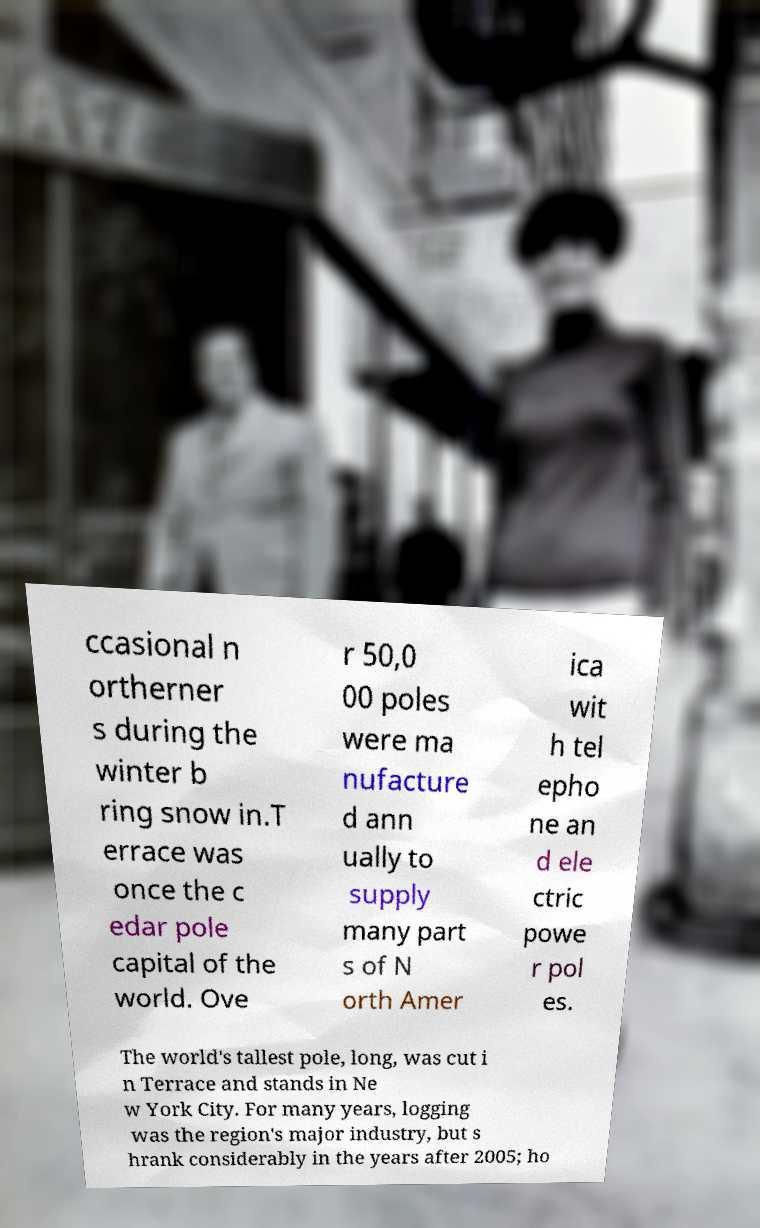What messages or text are displayed in this image? I need them in a readable, typed format. ccasional n ortherner s during the winter b ring snow in.T errace was once the c edar pole capital of the world. Ove r 50,0 00 poles were ma nufacture d ann ually to supply many part s of N orth Amer ica wit h tel epho ne an d ele ctric powe r pol es. The world's tallest pole, long, was cut i n Terrace and stands in Ne w York City. For many years, logging was the region's major industry, but s hrank considerably in the years after 2005; ho 